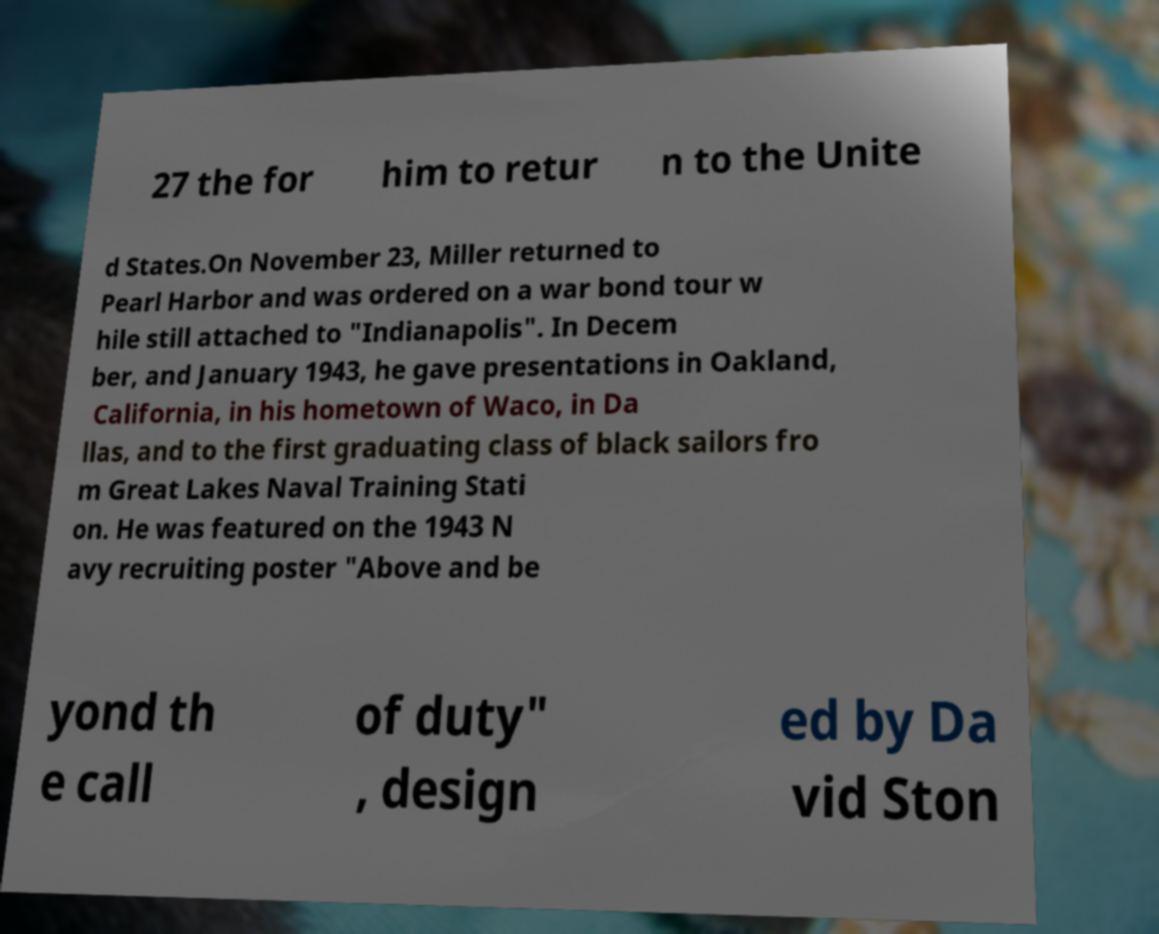Can you read and provide the text displayed in the image?This photo seems to have some interesting text. Can you extract and type it out for me? 27 the for him to retur n to the Unite d States.On November 23, Miller returned to Pearl Harbor and was ordered on a war bond tour w hile still attached to "Indianapolis". In Decem ber, and January 1943, he gave presentations in Oakland, California, in his hometown of Waco, in Da llas, and to the first graduating class of black sailors fro m Great Lakes Naval Training Stati on. He was featured on the 1943 N avy recruiting poster "Above and be yond th e call of duty" , design ed by Da vid Ston 